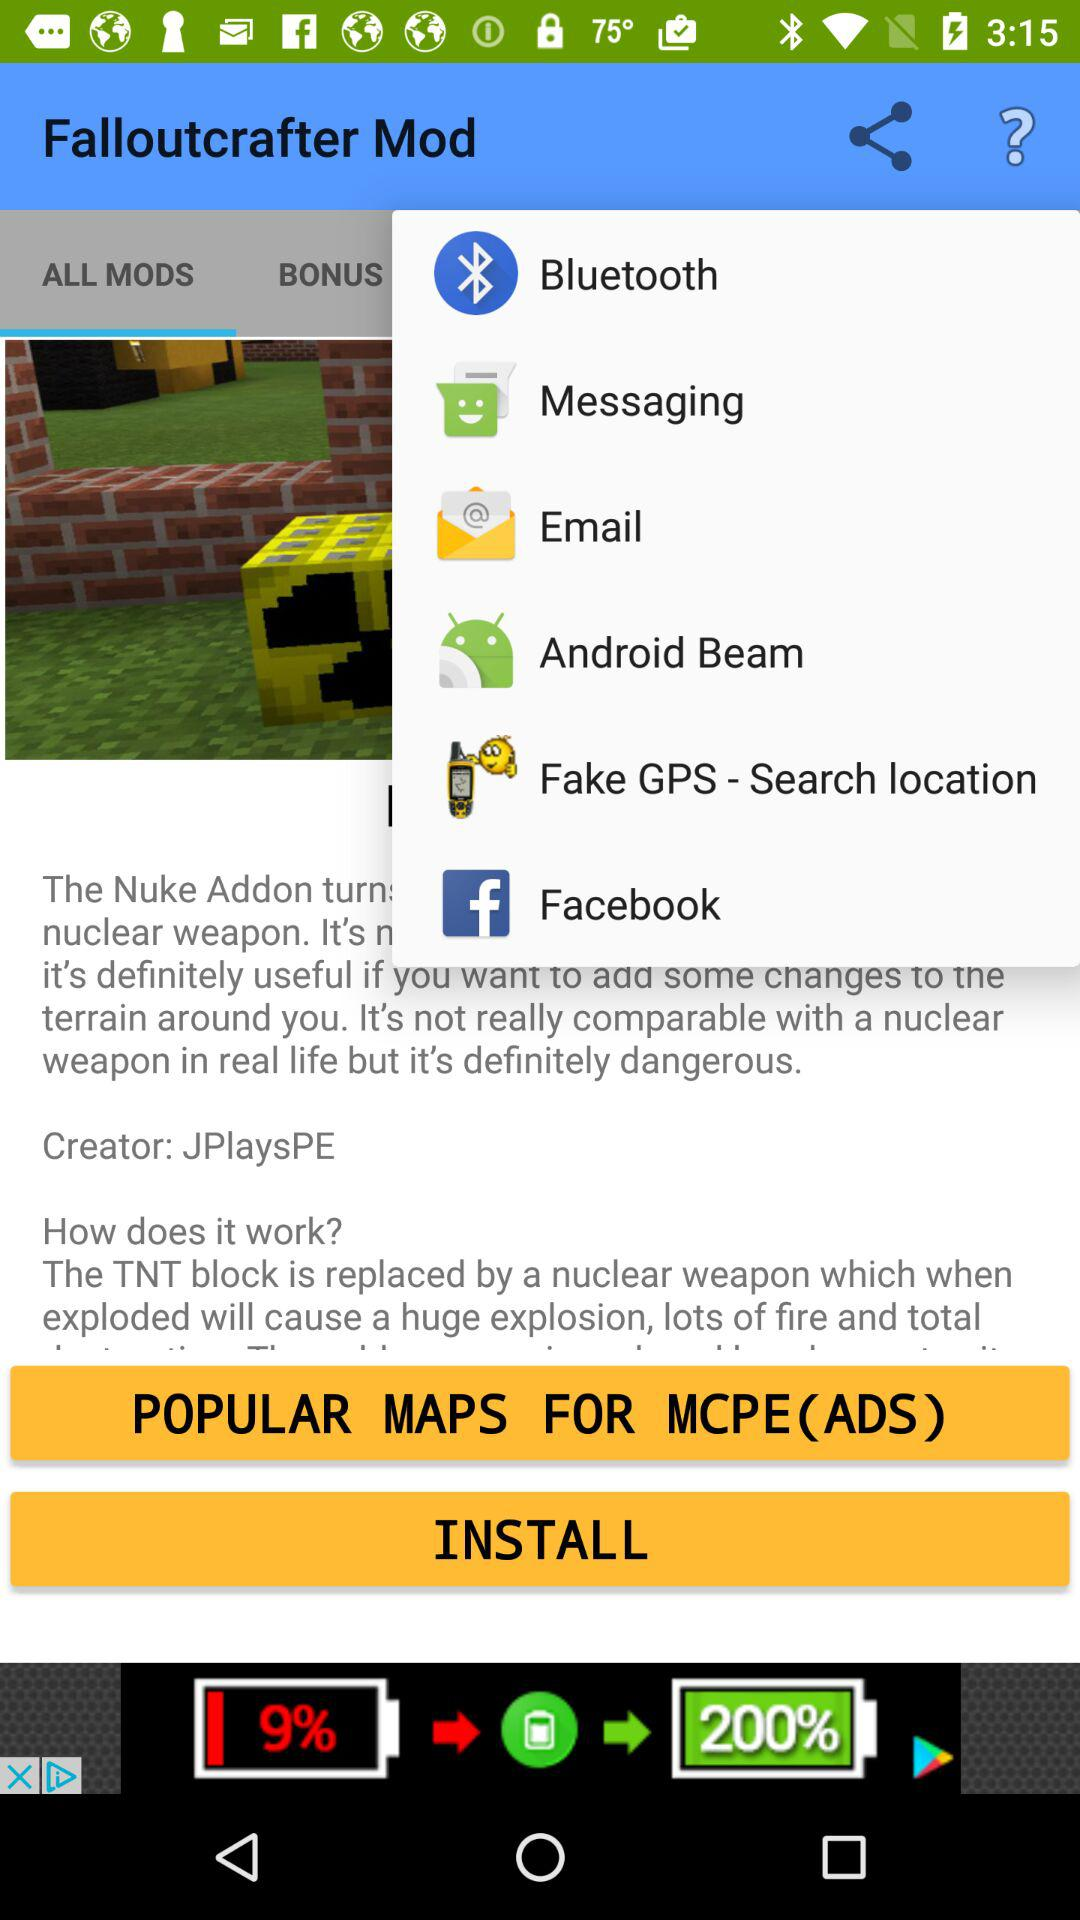What is the application name? The application name is "Falloutcrafter Mod". 